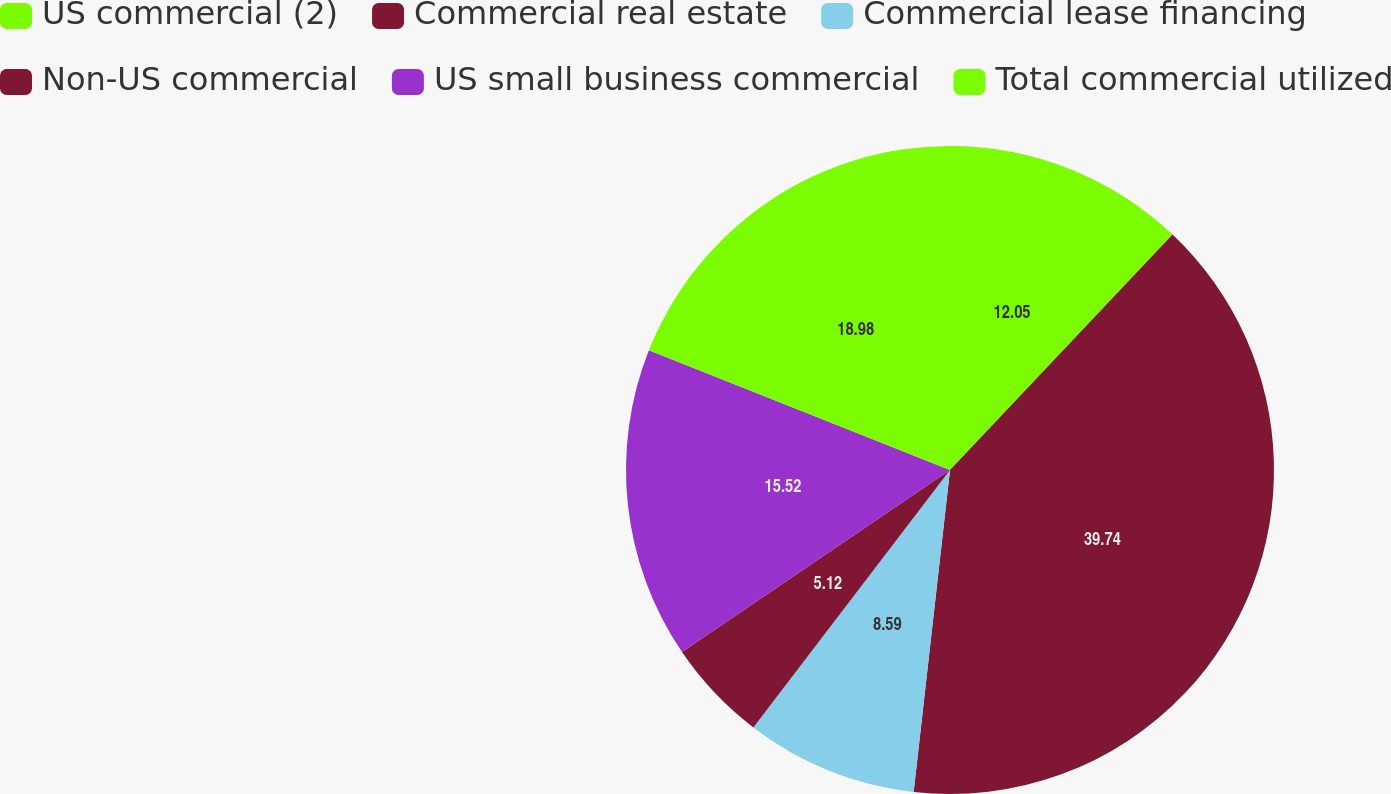<chart> <loc_0><loc_0><loc_500><loc_500><pie_chart><fcel>US commercial (2)<fcel>Commercial real estate<fcel>Commercial lease financing<fcel>Non-US commercial<fcel>US small business commercial<fcel>Total commercial utilized<nl><fcel>12.05%<fcel>39.74%<fcel>8.59%<fcel>5.12%<fcel>15.52%<fcel>18.98%<nl></chart> 